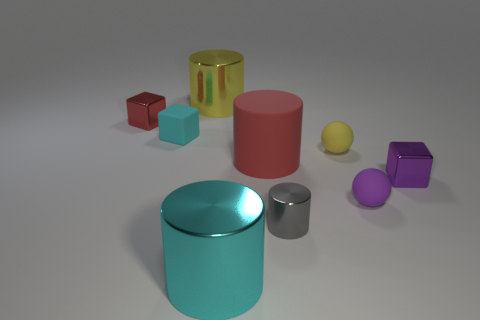What shape is the red metallic object that is the same size as the cyan matte block?
Offer a terse response. Cube. Is there a block of the same color as the matte cylinder?
Offer a very short reply. Yes. There is a big metal object that is in front of the small purple matte sphere; what shape is it?
Your response must be concise. Cylinder. The big matte cylinder is what color?
Provide a succinct answer. Red. There is a small block that is the same material as the large red object; what is its color?
Ensure brevity in your answer.  Cyan. How many red blocks have the same material as the big yellow cylinder?
Ensure brevity in your answer.  1. There is a red cylinder; what number of small cubes are right of it?
Give a very brief answer. 1. Do the yellow thing on the left side of the gray cylinder and the tiny sphere that is in front of the tiny purple metallic cube have the same material?
Offer a very short reply. No. Are there more small metallic things that are to the right of the large cyan metal thing than large metal cylinders that are in front of the tiny purple cube?
Provide a short and direct response. Yes. What is the material of the cylinder that is both behind the cyan shiny cylinder and in front of the red matte object?
Keep it short and to the point. Metal. 